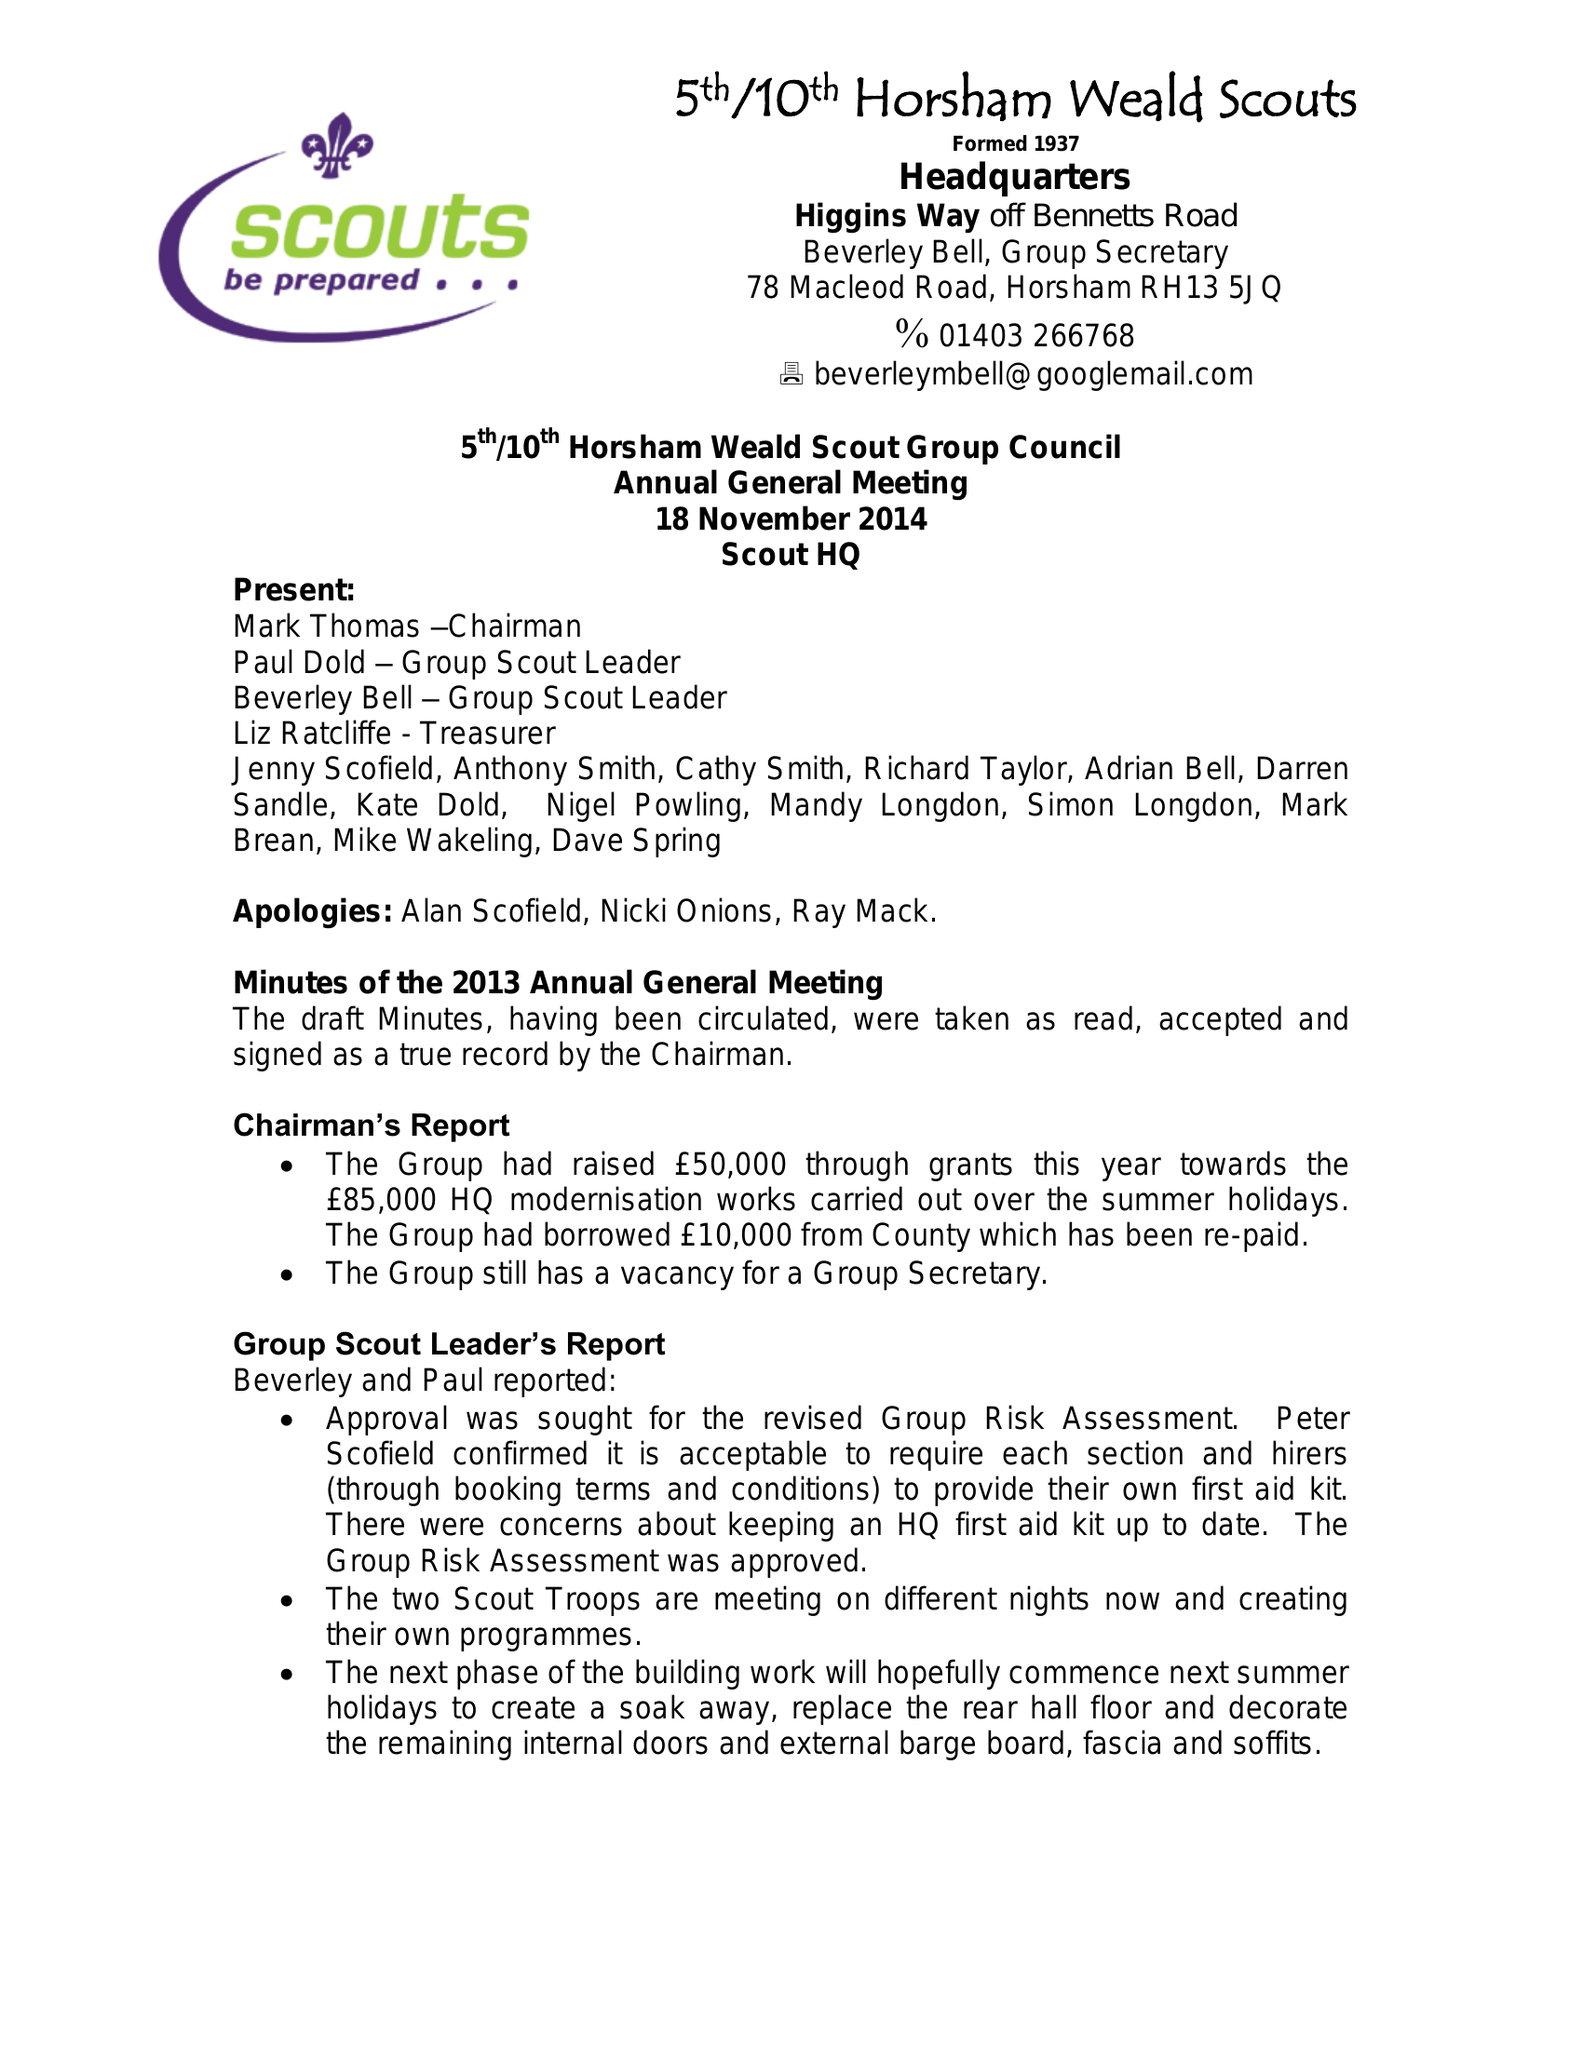What is the value for the address__street_line?
Answer the question using a single word or phrase. 20 DEVONSHIRE ROAD 